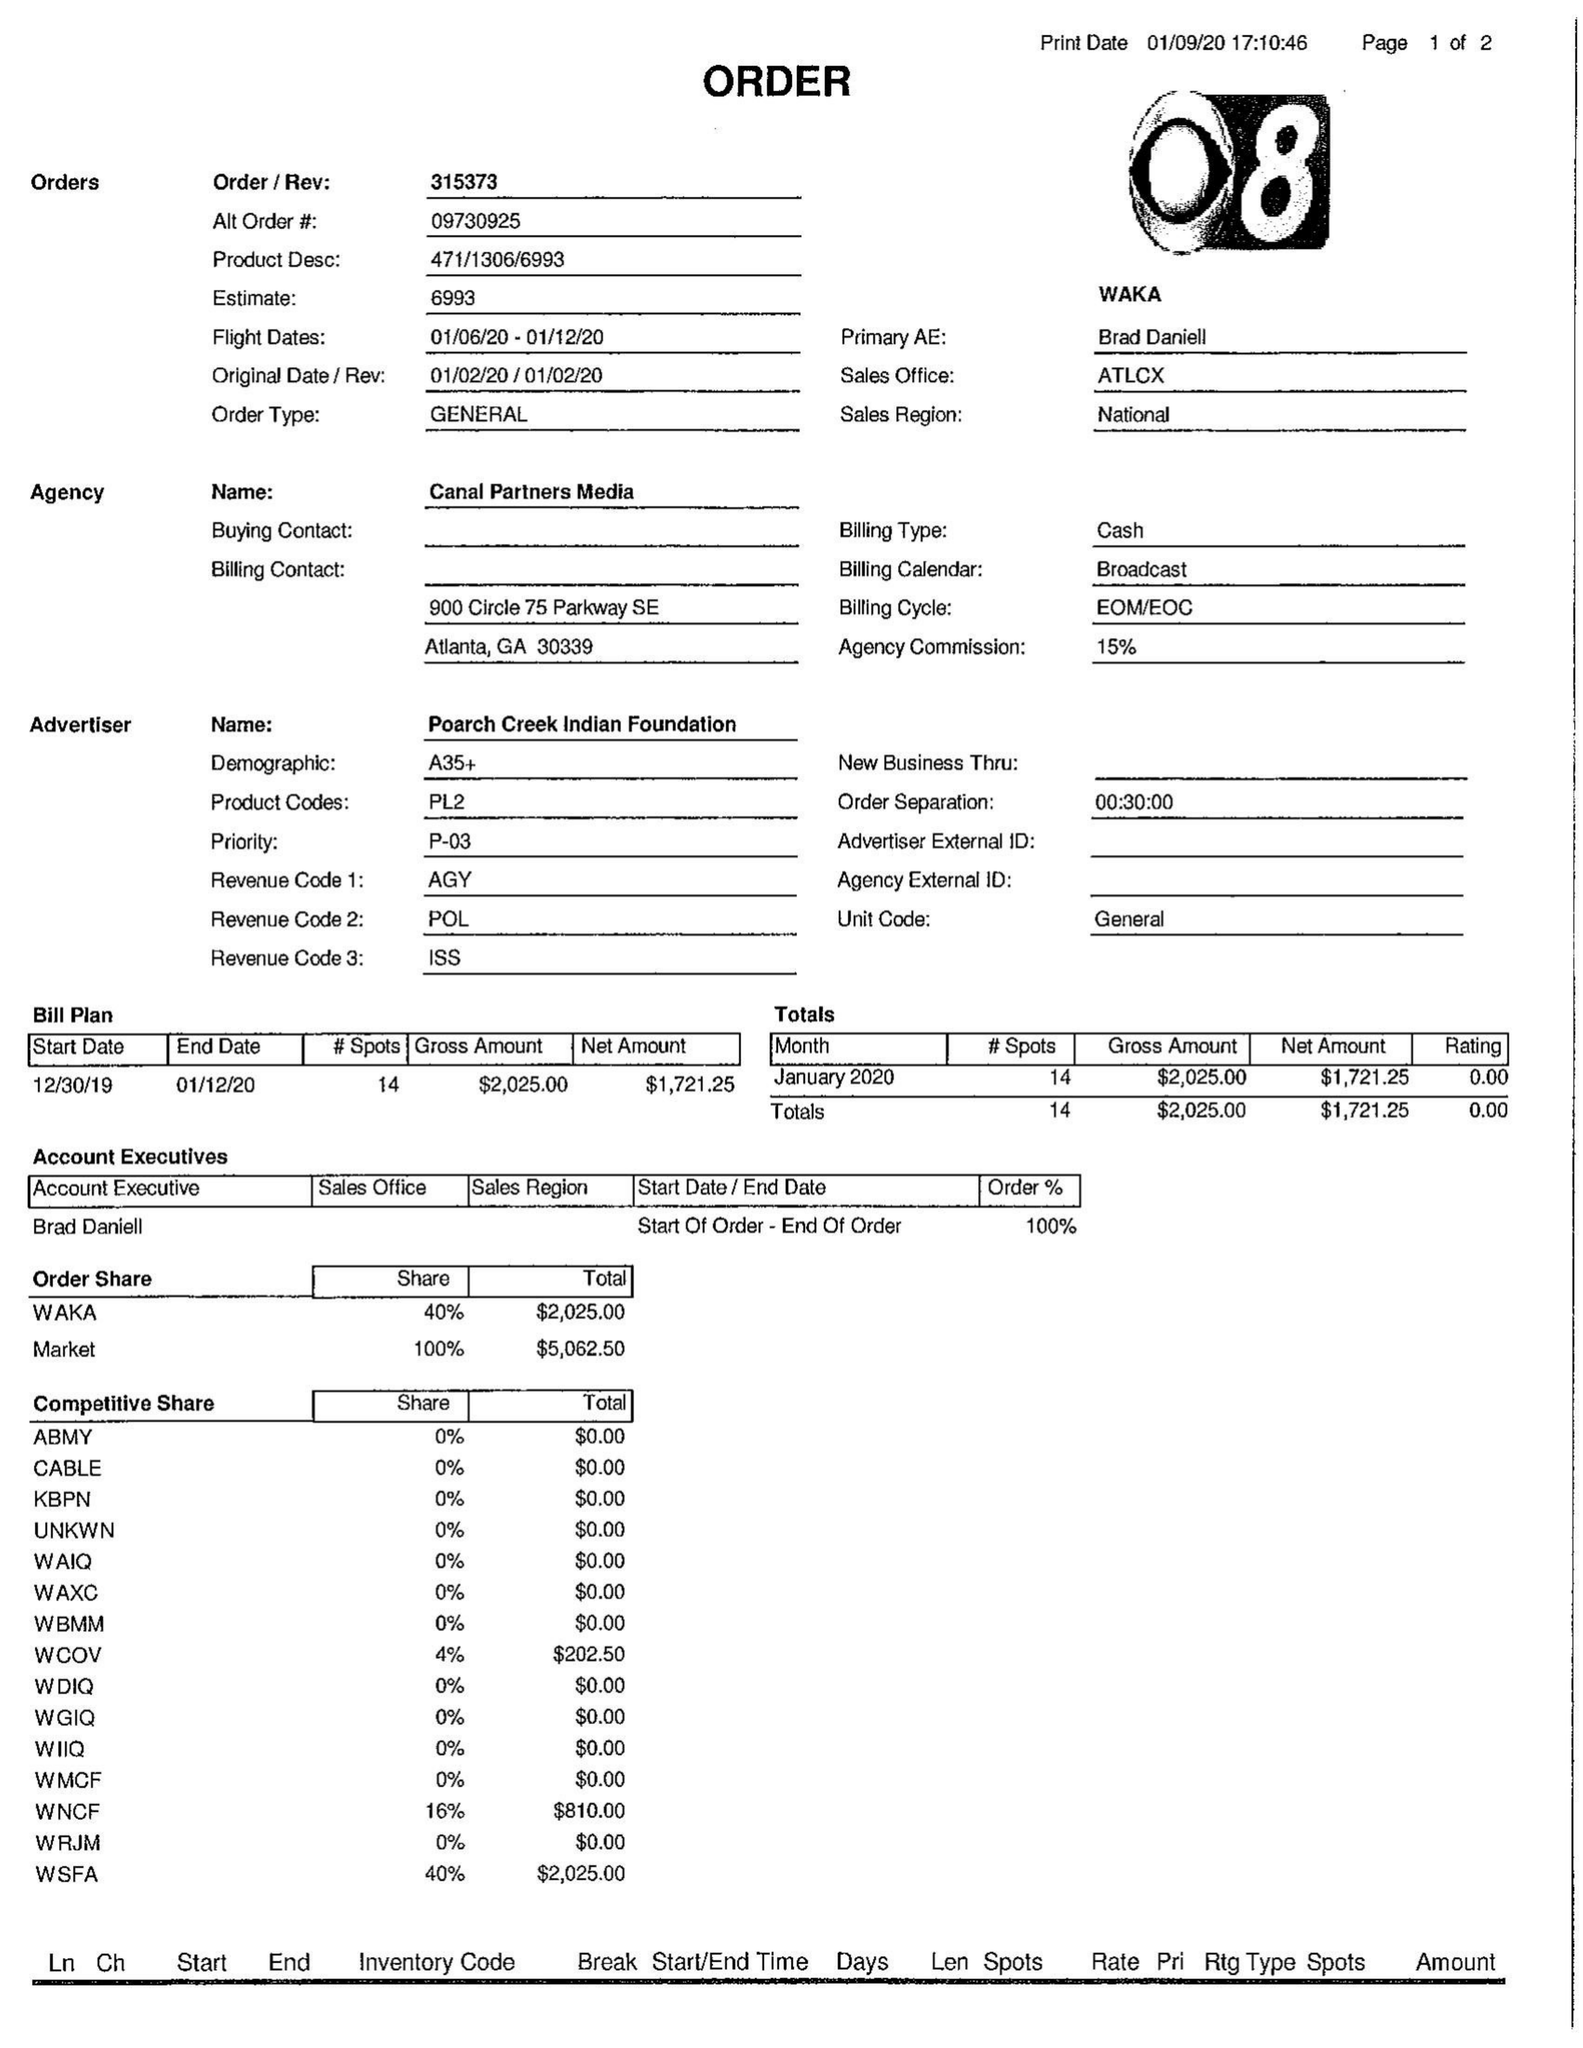What is the value for the flight_to?
Answer the question using a single word or phrase. 01/12/20 